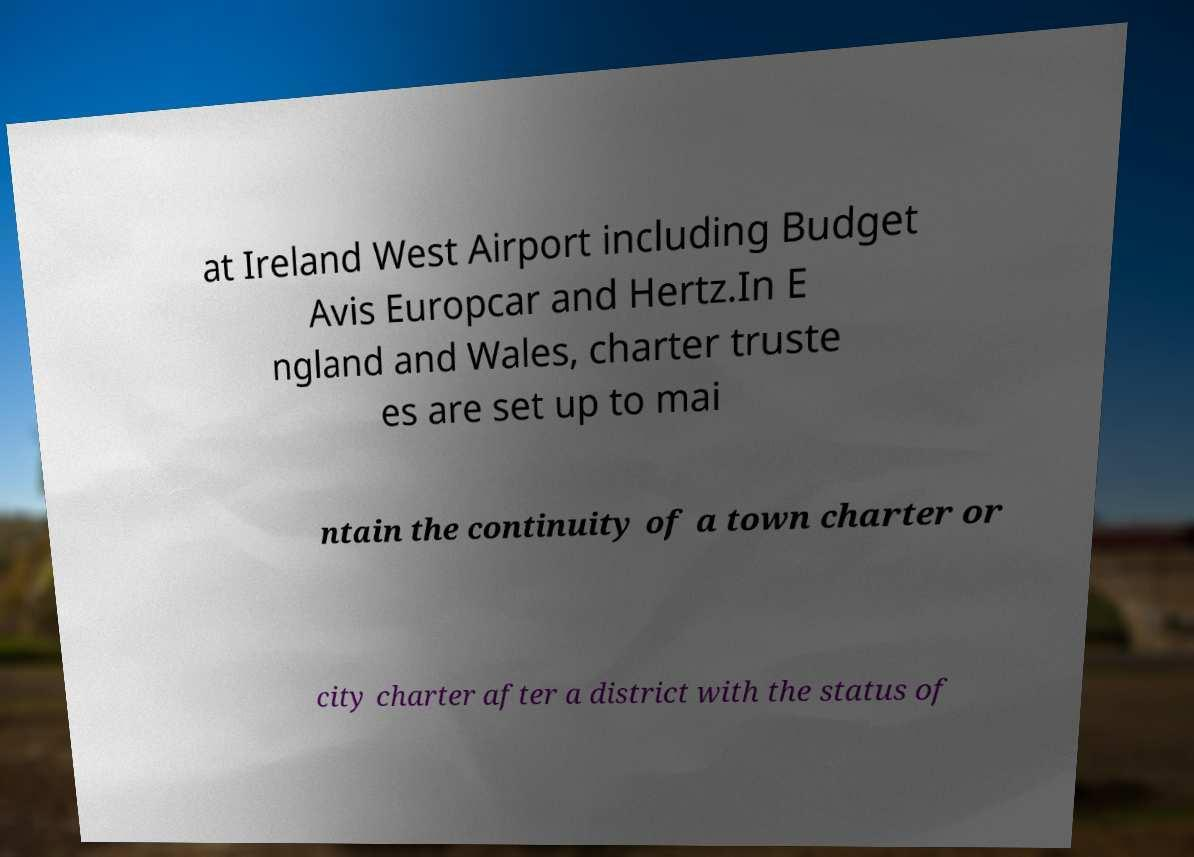I need the written content from this picture converted into text. Can you do that? at Ireland West Airport including Budget Avis Europcar and Hertz.In E ngland and Wales, charter truste es are set up to mai ntain the continuity of a town charter or city charter after a district with the status of 